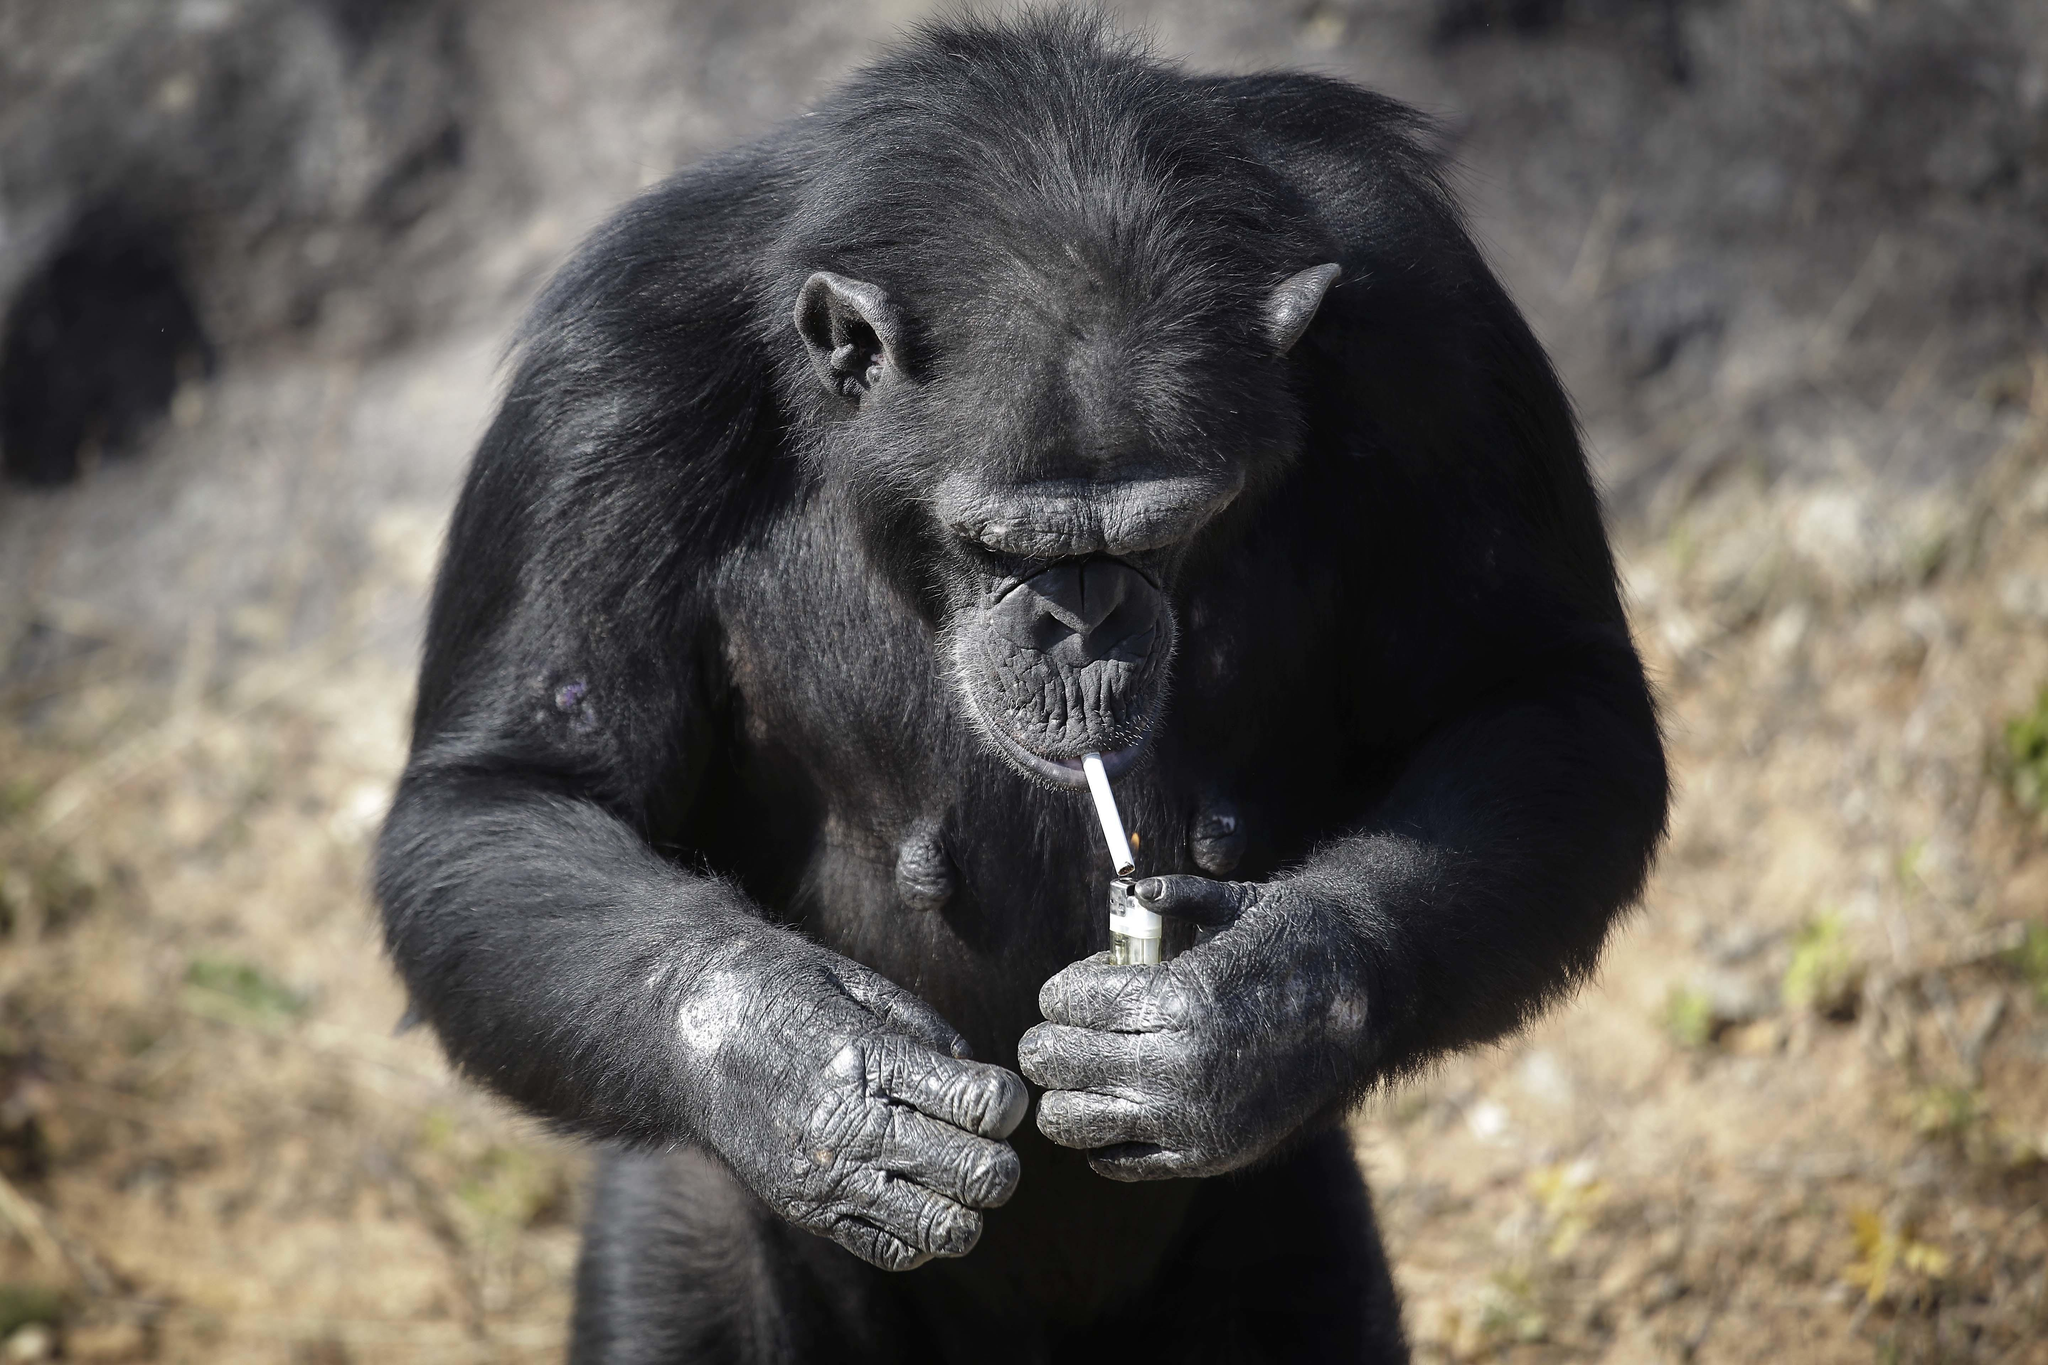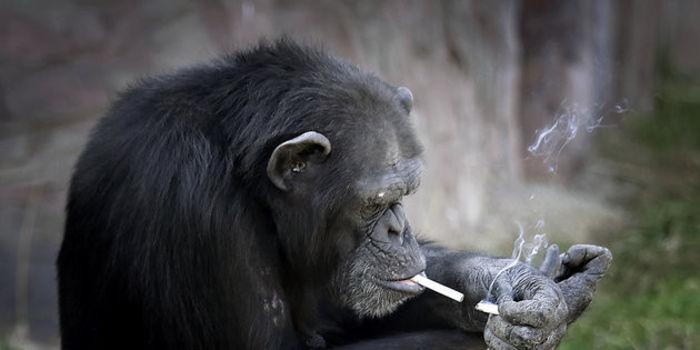The first image is the image on the left, the second image is the image on the right. Examine the images to the left and right. Is the description "At least one of the primates is smoking." accurate? Answer yes or no. Yes. 